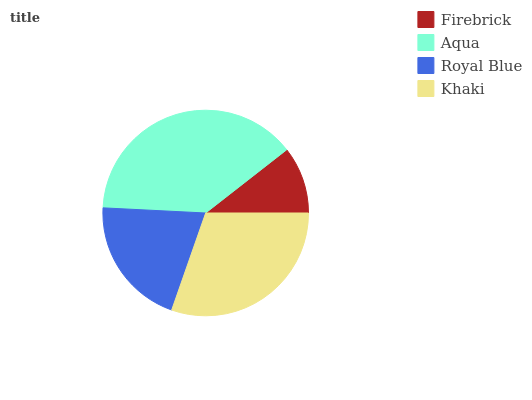Is Firebrick the minimum?
Answer yes or no. Yes. Is Aqua the maximum?
Answer yes or no. Yes. Is Royal Blue the minimum?
Answer yes or no. No. Is Royal Blue the maximum?
Answer yes or no. No. Is Aqua greater than Royal Blue?
Answer yes or no. Yes. Is Royal Blue less than Aqua?
Answer yes or no. Yes. Is Royal Blue greater than Aqua?
Answer yes or no. No. Is Aqua less than Royal Blue?
Answer yes or no. No. Is Khaki the high median?
Answer yes or no. Yes. Is Royal Blue the low median?
Answer yes or no. Yes. Is Firebrick the high median?
Answer yes or no. No. Is Firebrick the low median?
Answer yes or no. No. 